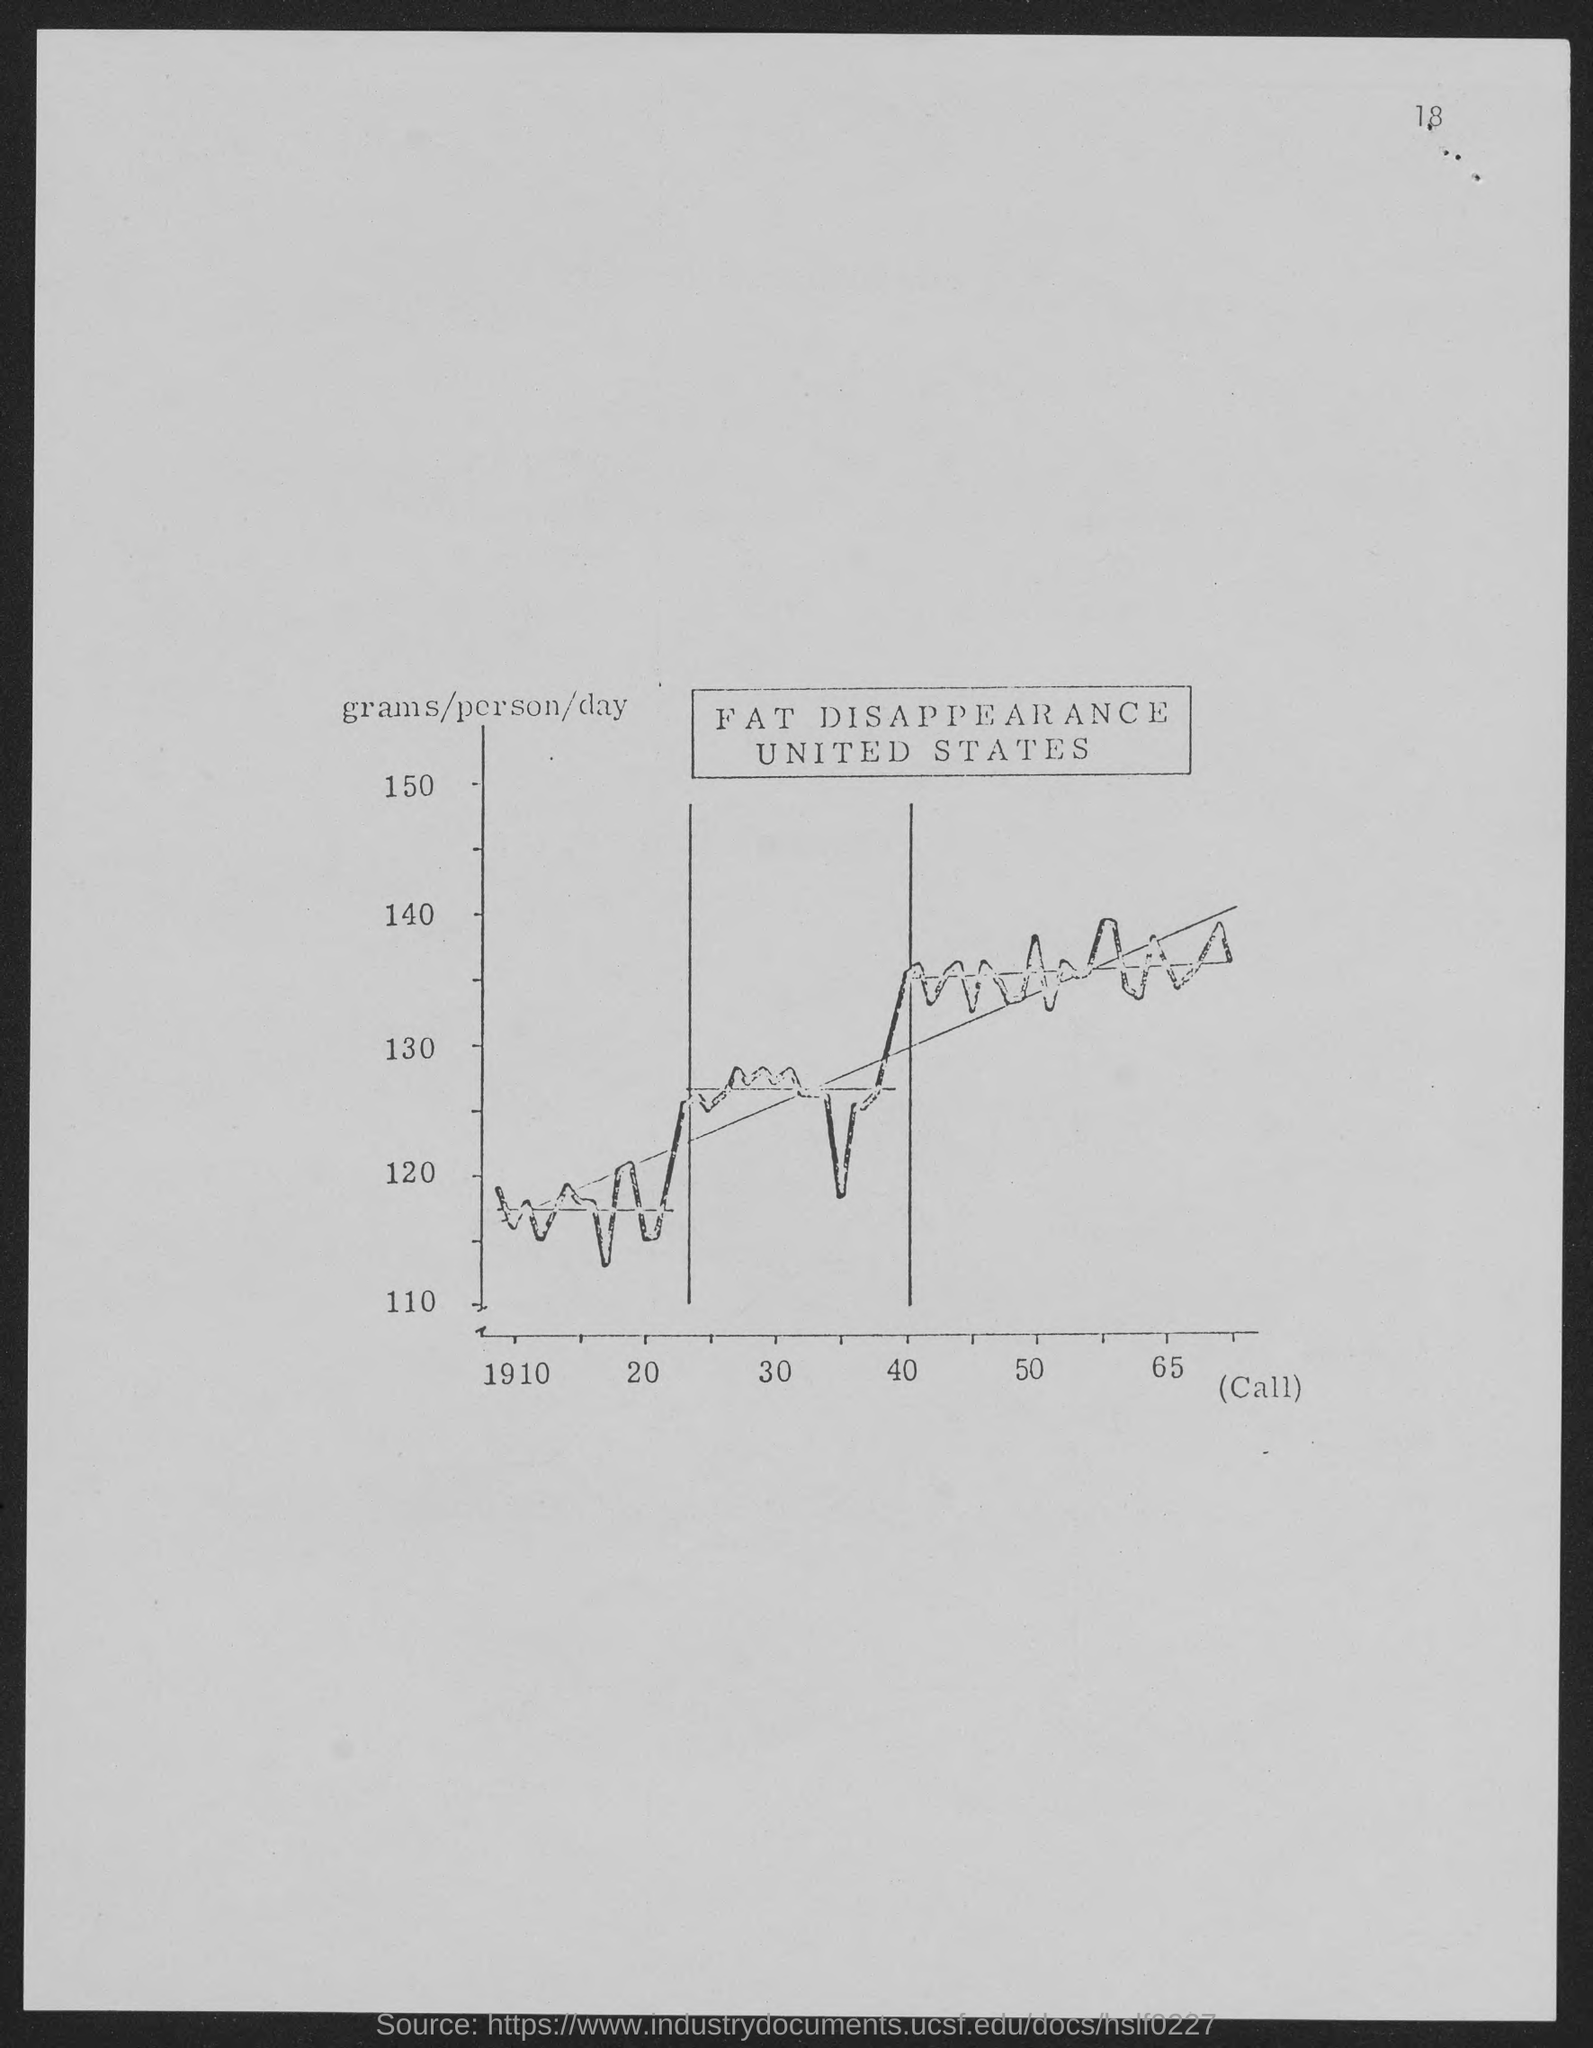Outline some significant characteristics in this image. The number at the top-right corner of the page is 18. 